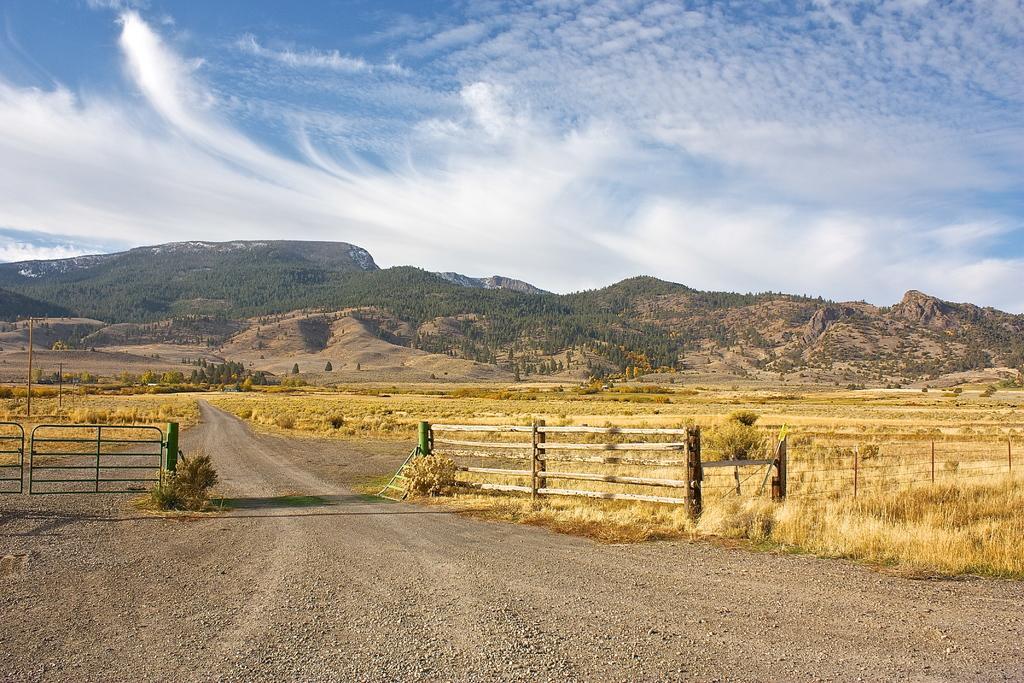In one or two sentences, can you explain what this image depicts? In this picture we can see the road, fence, grass, trees, mountains and in the background we can see the sky with clouds. 